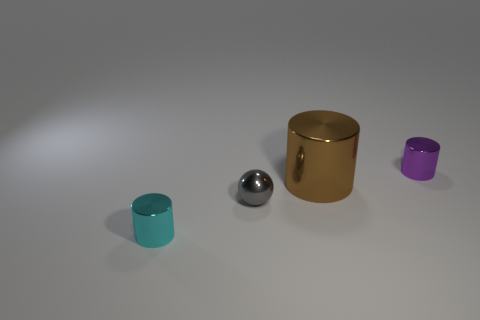What number of other things are there of the same size as the brown cylinder? There are no other objects of the same size as the brown cylinder in the image. Each object has a distinct size, with the brown cylinder being the largest amongst them. 